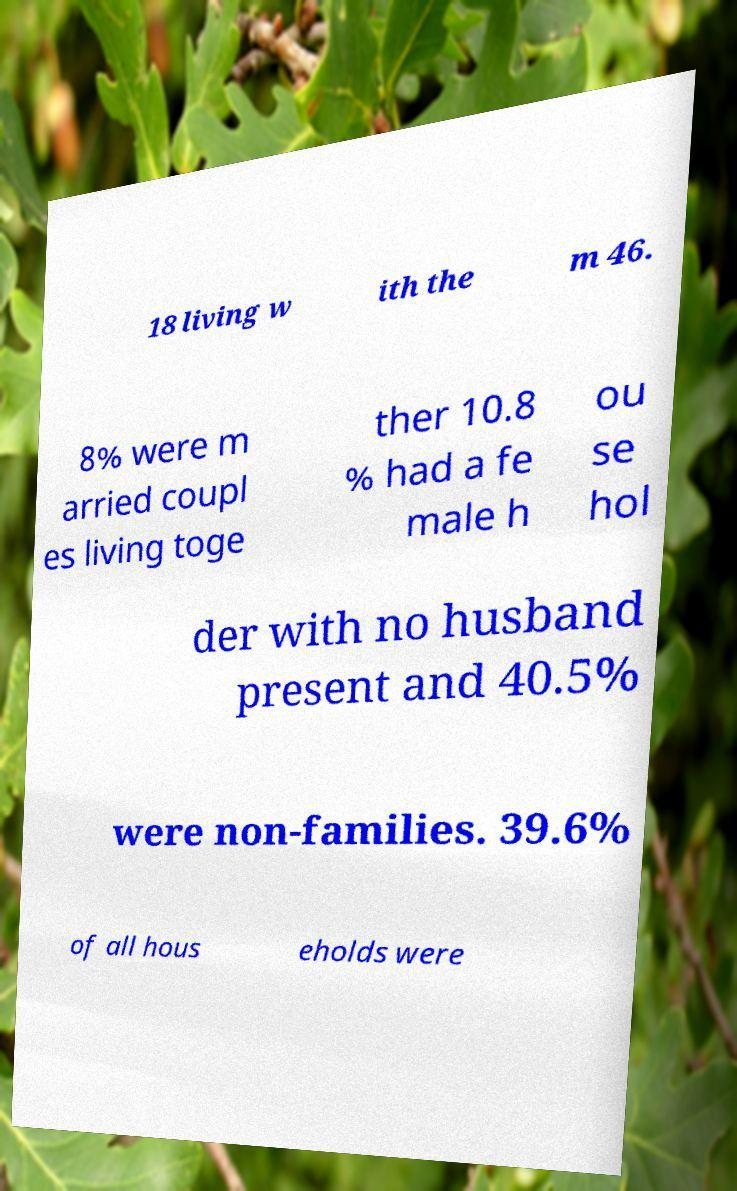Please identify and transcribe the text found in this image. 18 living w ith the m 46. 8% were m arried coupl es living toge ther 10.8 % had a fe male h ou se hol der with no husband present and 40.5% were non-families. 39.6% of all hous eholds were 